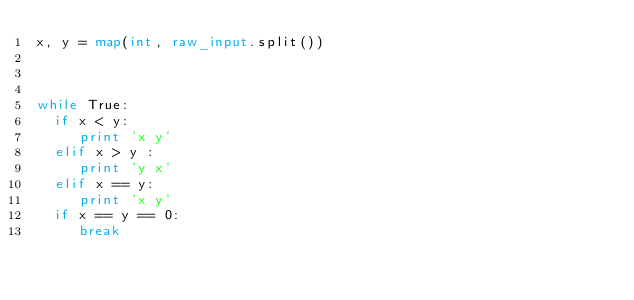<code> <loc_0><loc_0><loc_500><loc_500><_Python_>x, y = map(int, raw_input.split())



while True:
  if x < y:
     print 'x y'
  elif x > y :
     print 'y x'
  elif x == y:
     print 'x y'
  if x == y == 0:
     break

 </code> 